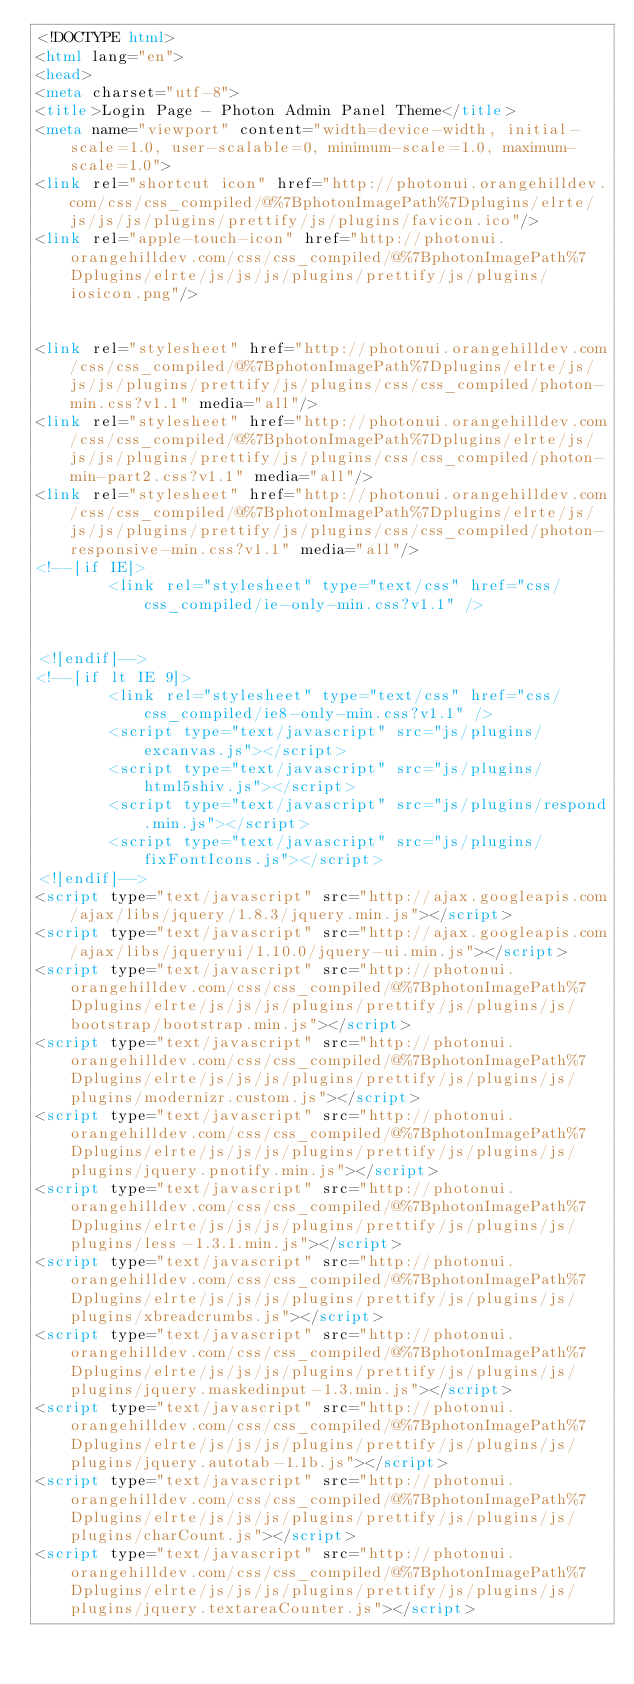Convert code to text. <code><loc_0><loc_0><loc_500><loc_500><_HTML_><!DOCTYPE html>
<html lang="en">
<head>
<meta charset="utf-8">
<title>Login Page - Photon Admin Panel Theme</title>
<meta name="viewport" content="width=device-width, initial-scale=1.0, user-scalable=0, minimum-scale=1.0, maximum-scale=1.0">
<link rel="shortcut icon" href="http://photonui.orangehilldev.com/css/css_compiled/@%7BphotonImagePath%7Dplugins/elrte/js/js/js/plugins/prettify/js/plugins/favicon.ico"/>
<link rel="apple-touch-icon" href="http://photonui.orangehilldev.com/css/css_compiled/@%7BphotonImagePath%7Dplugins/elrte/js/js/js/plugins/prettify/js/plugins/iosicon.png"/>
 
   
<link rel="stylesheet" href="http://photonui.orangehilldev.com/css/css_compiled/@%7BphotonImagePath%7Dplugins/elrte/js/js/js/plugins/prettify/js/plugins/css/css_compiled/photon-min.css?v1.1" media="all"/>
<link rel="stylesheet" href="http://photonui.orangehilldev.com/css/css_compiled/@%7BphotonImagePath%7Dplugins/elrte/js/js/js/plugins/prettify/js/plugins/css/css_compiled/photon-min-part2.css?v1.1" media="all"/>
<link rel="stylesheet" href="http://photonui.orangehilldev.com/css/css_compiled/@%7BphotonImagePath%7Dplugins/elrte/js/js/js/plugins/prettify/js/plugins/css/css_compiled/photon-responsive-min.css?v1.1" media="all"/>
<!--[if IE]>
        <link rel="stylesheet" type="text/css" href="css/css_compiled/ie-only-min.css?v1.1" />
        

<![endif]-->
<!--[if lt IE 9]>
        <link rel="stylesheet" type="text/css" href="css/css_compiled/ie8-only-min.css?v1.1" />
        <script type="text/javascript" src="js/plugins/excanvas.js"></script>
        <script type="text/javascript" src="js/plugins/html5shiv.js"></script>
        <script type="text/javascript" src="js/plugins/respond.min.js"></script>
        <script type="text/javascript" src="js/plugins/fixFontIcons.js"></script>
<![endif]-->
<script type="text/javascript" src="http://ajax.googleapis.com/ajax/libs/jquery/1.8.3/jquery.min.js"></script>
<script type="text/javascript" src="http://ajax.googleapis.com/ajax/libs/jqueryui/1.10.0/jquery-ui.min.js"></script>
<script type="text/javascript" src="http://photonui.orangehilldev.com/css/css_compiled/@%7BphotonImagePath%7Dplugins/elrte/js/js/js/plugins/prettify/js/plugins/js/bootstrap/bootstrap.min.js"></script>
<script type="text/javascript" src="http://photonui.orangehilldev.com/css/css_compiled/@%7BphotonImagePath%7Dplugins/elrte/js/js/js/plugins/prettify/js/plugins/js/plugins/modernizr.custom.js"></script>
<script type="text/javascript" src="http://photonui.orangehilldev.com/css/css_compiled/@%7BphotonImagePath%7Dplugins/elrte/js/js/js/plugins/prettify/js/plugins/js/plugins/jquery.pnotify.min.js"></script>
<script type="text/javascript" src="http://photonui.orangehilldev.com/css/css_compiled/@%7BphotonImagePath%7Dplugins/elrte/js/js/js/plugins/prettify/js/plugins/js/plugins/less-1.3.1.min.js"></script>
<script type="text/javascript" src="http://photonui.orangehilldev.com/css/css_compiled/@%7BphotonImagePath%7Dplugins/elrte/js/js/js/plugins/prettify/js/plugins/js/plugins/xbreadcrumbs.js"></script>
<script type="text/javascript" src="http://photonui.orangehilldev.com/css/css_compiled/@%7BphotonImagePath%7Dplugins/elrte/js/js/js/plugins/prettify/js/plugins/js/plugins/jquery.maskedinput-1.3.min.js"></script>
<script type="text/javascript" src="http://photonui.orangehilldev.com/css/css_compiled/@%7BphotonImagePath%7Dplugins/elrte/js/js/js/plugins/prettify/js/plugins/js/plugins/jquery.autotab-1.1b.js"></script>
<script type="text/javascript" src="http://photonui.orangehilldev.com/css/css_compiled/@%7BphotonImagePath%7Dplugins/elrte/js/js/js/plugins/prettify/js/plugins/js/plugins/charCount.js"></script>
<script type="text/javascript" src="http://photonui.orangehilldev.com/css/css_compiled/@%7BphotonImagePath%7Dplugins/elrte/js/js/js/plugins/prettify/js/plugins/js/plugins/jquery.textareaCounter.js"></script></code> 